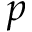<formula> <loc_0><loc_0><loc_500><loc_500>p</formula> 